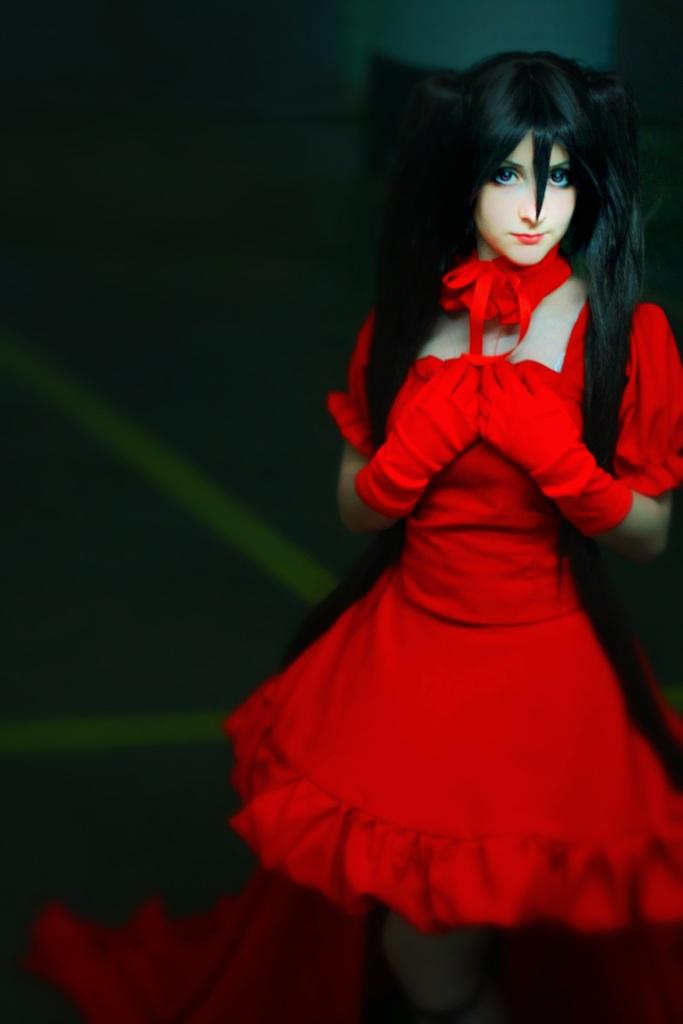Who is the main subject in the image? There is a woman in the image. What is the woman wearing? The woman is wearing a red dress and gloves. What can be observed about the background of the image? The background of the image is dark. What type of throne is the woman sitting on in the image? There is no throne present in the image; the woman is not sitting on anything. 